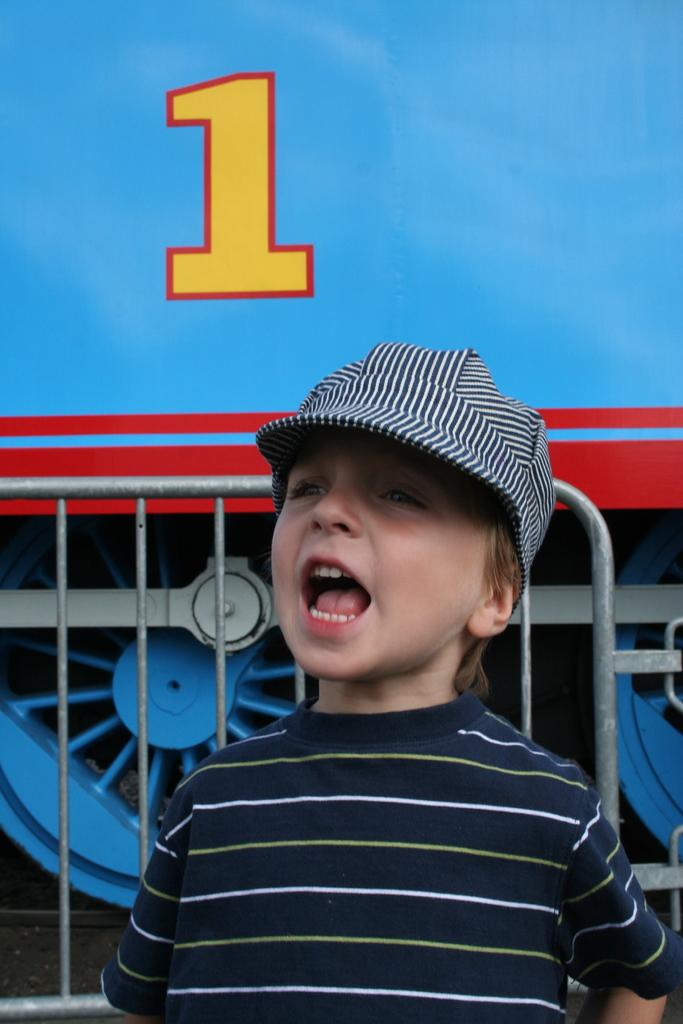Who is the main subject in the image? There is a child in the image. What is the child wearing on their head? The child is wearing a cap. What objects can be seen in the image besides the child? There are rods in the image. What can be seen in the background of the image? There is a vehicle in the background of the image. What type of can is visible in the image? There is no can present in the image. What message of peace can be seen in the image? There is no message of peace depicted in the image. 